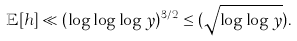<formula> <loc_0><loc_0><loc_500><loc_500>\mathbb { E } [ h ] \ll ( \log \log \log y ) ^ { 3 / 2 } \leq ( \sqrt { \log \log y } ) .</formula> 